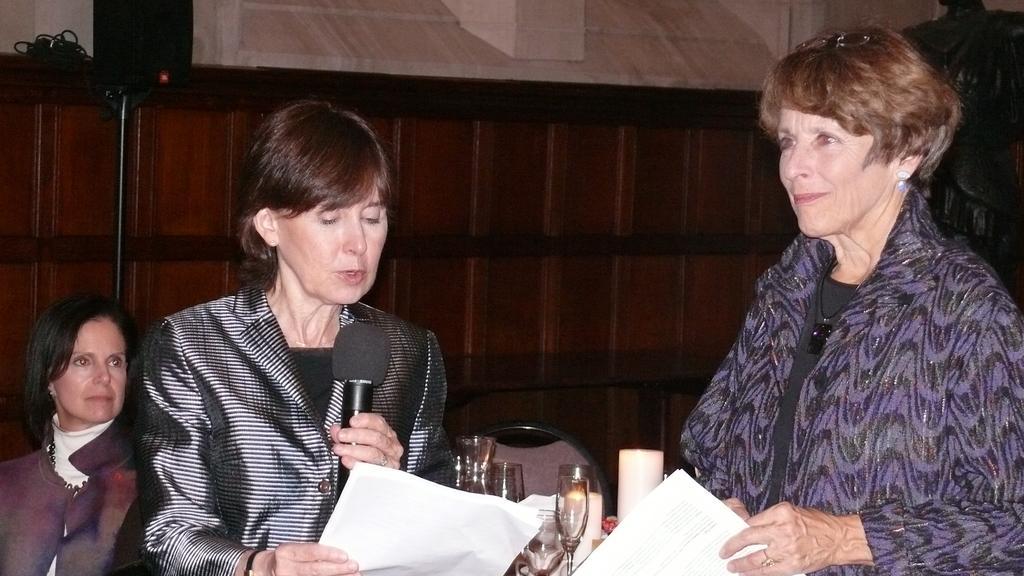How would you summarize this image in a sentence or two? Two women are standing holding microphone,paper and here there is glass,chair. 